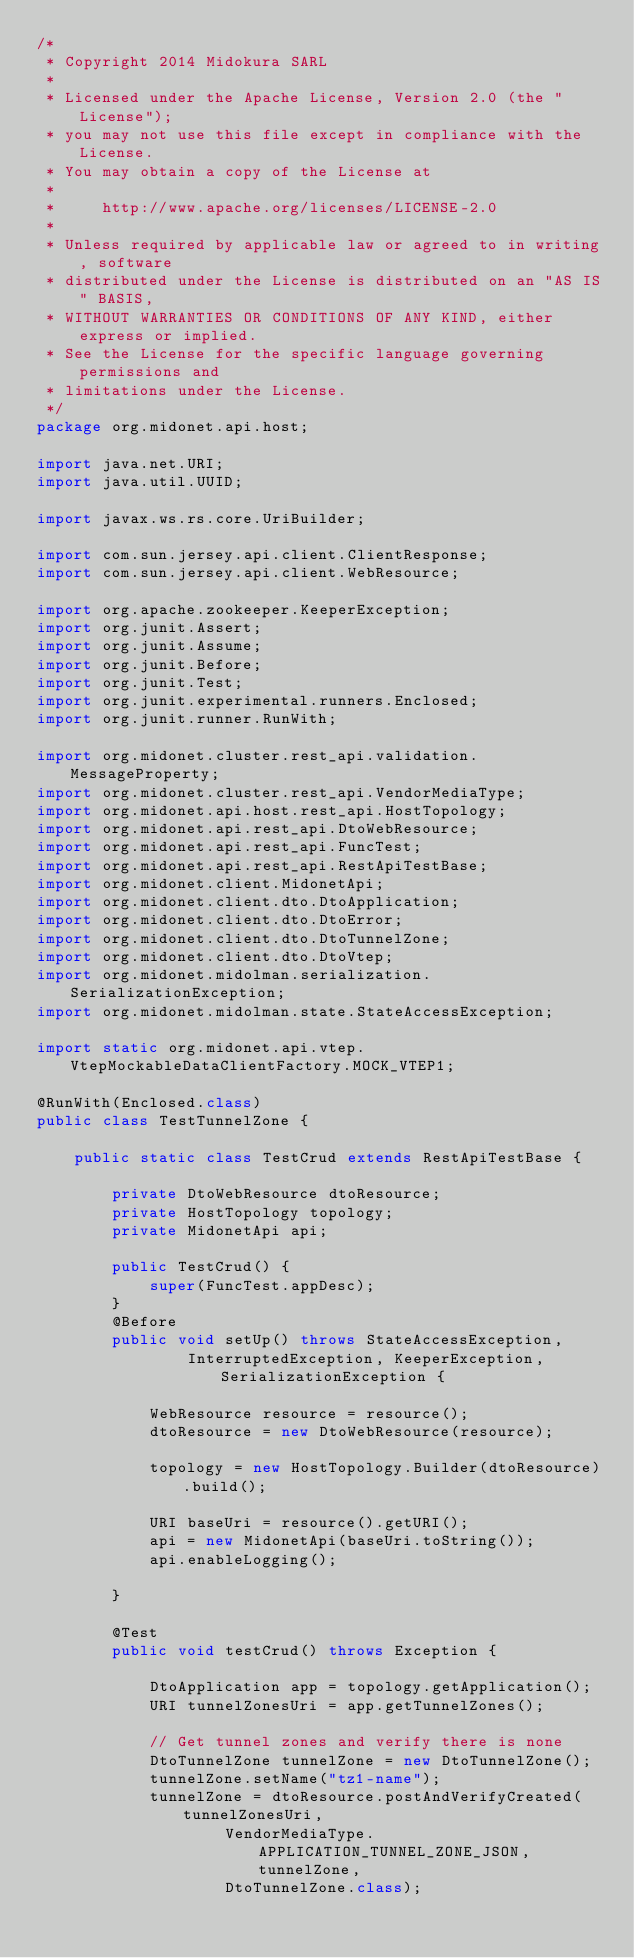<code> <loc_0><loc_0><loc_500><loc_500><_Java_>/*
 * Copyright 2014 Midokura SARL
 *
 * Licensed under the Apache License, Version 2.0 (the "License");
 * you may not use this file except in compliance with the License.
 * You may obtain a copy of the License at
 *
 *     http://www.apache.org/licenses/LICENSE-2.0
 *
 * Unless required by applicable law or agreed to in writing, software
 * distributed under the License is distributed on an "AS IS" BASIS,
 * WITHOUT WARRANTIES OR CONDITIONS OF ANY KIND, either express or implied.
 * See the License for the specific language governing permissions and
 * limitations under the License.
 */
package org.midonet.api.host;

import java.net.URI;
import java.util.UUID;

import javax.ws.rs.core.UriBuilder;

import com.sun.jersey.api.client.ClientResponse;
import com.sun.jersey.api.client.WebResource;

import org.apache.zookeeper.KeeperException;
import org.junit.Assert;
import org.junit.Assume;
import org.junit.Before;
import org.junit.Test;
import org.junit.experimental.runners.Enclosed;
import org.junit.runner.RunWith;

import org.midonet.cluster.rest_api.validation.MessageProperty;
import org.midonet.cluster.rest_api.VendorMediaType;
import org.midonet.api.host.rest_api.HostTopology;
import org.midonet.api.rest_api.DtoWebResource;
import org.midonet.api.rest_api.FuncTest;
import org.midonet.api.rest_api.RestApiTestBase;
import org.midonet.client.MidonetApi;
import org.midonet.client.dto.DtoApplication;
import org.midonet.client.dto.DtoError;
import org.midonet.client.dto.DtoTunnelZone;
import org.midonet.client.dto.DtoVtep;
import org.midonet.midolman.serialization.SerializationException;
import org.midonet.midolman.state.StateAccessException;

import static org.midonet.api.vtep.VtepMockableDataClientFactory.MOCK_VTEP1;

@RunWith(Enclosed.class)
public class TestTunnelZone {

    public static class TestCrud extends RestApiTestBase {

        private DtoWebResource dtoResource;
        private HostTopology topology;
        private MidonetApi api;

        public TestCrud() {
            super(FuncTest.appDesc);
        }
        @Before
        public void setUp() throws StateAccessException,
                InterruptedException, KeeperException, SerializationException {

            WebResource resource = resource();
            dtoResource = new DtoWebResource(resource);

            topology = new HostTopology.Builder(dtoResource).build();

            URI baseUri = resource().getURI();
            api = new MidonetApi(baseUri.toString());
            api.enableLogging();

        }

        @Test
        public void testCrud() throws Exception {

            DtoApplication app = topology.getApplication();
            URI tunnelZonesUri = app.getTunnelZones();

            // Get tunnel zones and verify there is none
            DtoTunnelZone tunnelZone = new DtoTunnelZone();
            tunnelZone.setName("tz1-name");
            tunnelZone = dtoResource.postAndVerifyCreated(tunnelZonesUri,
                    VendorMediaType.APPLICATION_TUNNEL_ZONE_JSON, tunnelZone,
                    DtoTunnelZone.class);</code> 